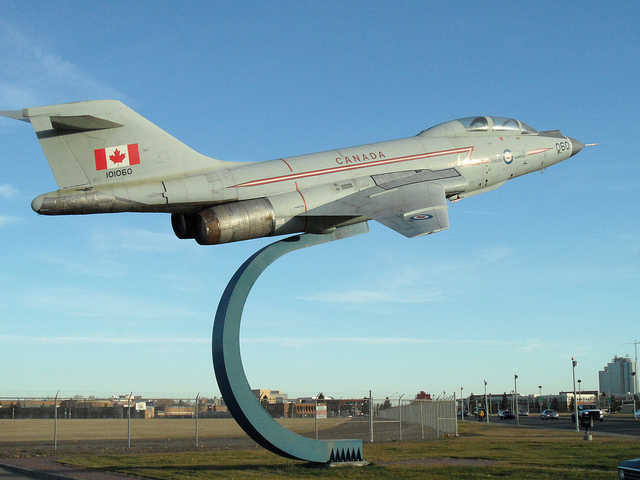Read and extract the text from this image. CANADA 101080 060 